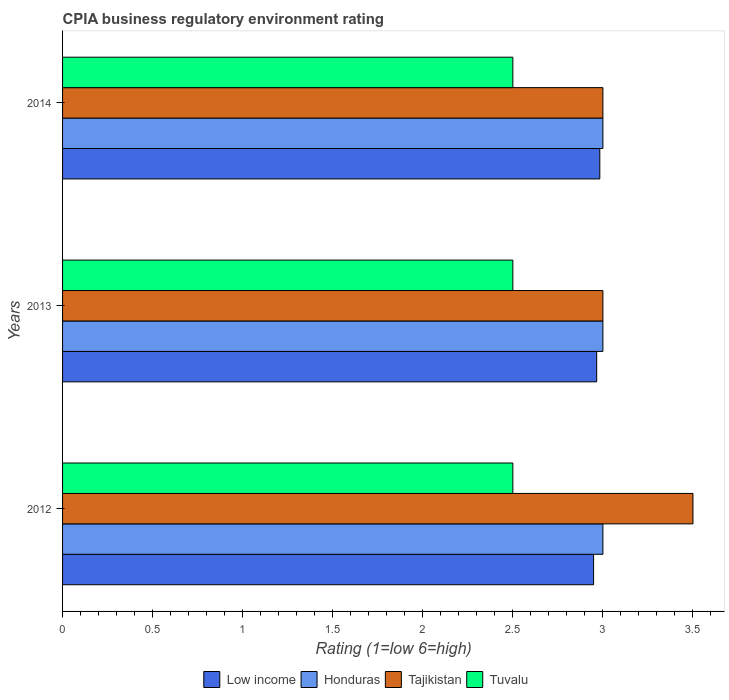How many different coloured bars are there?
Keep it short and to the point. 4. Are the number of bars per tick equal to the number of legend labels?
Make the answer very short. Yes. How many bars are there on the 2nd tick from the bottom?
Keep it short and to the point. 4. What is the CPIA rating in Honduras in 2014?
Give a very brief answer. 3. Across all years, what is the minimum CPIA rating in Low income?
Ensure brevity in your answer.  2.95. In which year was the CPIA rating in Low income minimum?
Keep it short and to the point. 2012. What is the total CPIA rating in Low income in the graph?
Offer a terse response. 8.9. What is the difference between the CPIA rating in Tajikistan in 2013 and that in 2014?
Offer a terse response. 0. What is the difference between the CPIA rating in Tuvalu in 2013 and the CPIA rating in Low income in 2012?
Provide a short and direct response. -0.45. What is the average CPIA rating in Tajikistan per year?
Your answer should be compact. 3.17. In the year 2012, what is the difference between the CPIA rating in Honduras and CPIA rating in Low income?
Give a very brief answer. 0.05. In how many years, is the CPIA rating in Honduras greater than 0.5 ?
Keep it short and to the point. 3. What is the ratio of the CPIA rating in Low income in 2012 to that in 2013?
Provide a short and direct response. 0.99. What is the difference between the highest and the second highest CPIA rating in Tuvalu?
Offer a terse response. 0. In how many years, is the CPIA rating in Honduras greater than the average CPIA rating in Honduras taken over all years?
Provide a succinct answer. 0. Is the sum of the CPIA rating in Honduras in 2012 and 2014 greater than the maximum CPIA rating in Tuvalu across all years?
Give a very brief answer. Yes. What does the 2nd bar from the top in 2013 represents?
Offer a terse response. Tajikistan. What does the 1st bar from the bottom in 2013 represents?
Provide a succinct answer. Low income. What is the difference between two consecutive major ticks on the X-axis?
Provide a short and direct response. 0.5. Does the graph contain any zero values?
Ensure brevity in your answer.  No. Does the graph contain grids?
Give a very brief answer. No. Where does the legend appear in the graph?
Provide a succinct answer. Bottom center. How many legend labels are there?
Your answer should be very brief. 4. What is the title of the graph?
Ensure brevity in your answer.  CPIA business regulatory environment rating. What is the label or title of the X-axis?
Offer a very short reply. Rating (1=low 6=high). What is the Rating (1=low 6=high) of Low income in 2012?
Offer a terse response. 2.95. What is the Rating (1=low 6=high) in Low income in 2013?
Your answer should be compact. 2.97. What is the Rating (1=low 6=high) of Honduras in 2013?
Your response must be concise. 3. What is the Rating (1=low 6=high) of Tuvalu in 2013?
Your response must be concise. 2.5. What is the Rating (1=low 6=high) in Low income in 2014?
Offer a terse response. 2.98. What is the Rating (1=low 6=high) of Honduras in 2014?
Your answer should be compact. 3. What is the Rating (1=low 6=high) in Tajikistan in 2014?
Offer a terse response. 3. Across all years, what is the maximum Rating (1=low 6=high) in Low income?
Your answer should be compact. 2.98. Across all years, what is the minimum Rating (1=low 6=high) in Low income?
Your response must be concise. 2.95. Across all years, what is the minimum Rating (1=low 6=high) in Tajikistan?
Give a very brief answer. 3. What is the total Rating (1=low 6=high) of Low income in the graph?
Your answer should be very brief. 8.9. What is the total Rating (1=low 6=high) in Honduras in the graph?
Provide a succinct answer. 9. What is the difference between the Rating (1=low 6=high) of Low income in 2012 and that in 2013?
Offer a terse response. -0.02. What is the difference between the Rating (1=low 6=high) of Tajikistan in 2012 and that in 2013?
Keep it short and to the point. 0.5. What is the difference between the Rating (1=low 6=high) of Low income in 2012 and that in 2014?
Your answer should be compact. -0.03. What is the difference between the Rating (1=low 6=high) of Tuvalu in 2012 and that in 2014?
Give a very brief answer. 0. What is the difference between the Rating (1=low 6=high) in Low income in 2013 and that in 2014?
Provide a short and direct response. -0.02. What is the difference between the Rating (1=low 6=high) of Low income in 2012 and the Rating (1=low 6=high) of Honduras in 2013?
Your response must be concise. -0.05. What is the difference between the Rating (1=low 6=high) of Low income in 2012 and the Rating (1=low 6=high) of Tajikistan in 2013?
Make the answer very short. -0.05. What is the difference between the Rating (1=low 6=high) in Low income in 2012 and the Rating (1=low 6=high) in Tuvalu in 2013?
Keep it short and to the point. 0.45. What is the difference between the Rating (1=low 6=high) of Honduras in 2012 and the Rating (1=low 6=high) of Tajikistan in 2013?
Keep it short and to the point. 0. What is the difference between the Rating (1=low 6=high) of Honduras in 2012 and the Rating (1=low 6=high) of Tuvalu in 2013?
Provide a short and direct response. 0.5. What is the difference between the Rating (1=low 6=high) in Tajikistan in 2012 and the Rating (1=low 6=high) in Tuvalu in 2013?
Make the answer very short. 1. What is the difference between the Rating (1=low 6=high) of Low income in 2012 and the Rating (1=low 6=high) of Honduras in 2014?
Keep it short and to the point. -0.05. What is the difference between the Rating (1=low 6=high) in Low income in 2012 and the Rating (1=low 6=high) in Tajikistan in 2014?
Your response must be concise. -0.05. What is the difference between the Rating (1=low 6=high) of Low income in 2012 and the Rating (1=low 6=high) of Tuvalu in 2014?
Offer a very short reply. 0.45. What is the difference between the Rating (1=low 6=high) of Tajikistan in 2012 and the Rating (1=low 6=high) of Tuvalu in 2014?
Your answer should be compact. 1. What is the difference between the Rating (1=low 6=high) of Low income in 2013 and the Rating (1=low 6=high) of Honduras in 2014?
Your answer should be compact. -0.03. What is the difference between the Rating (1=low 6=high) in Low income in 2013 and the Rating (1=low 6=high) in Tajikistan in 2014?
Make the answer very short. -0.03. What is the difference between the Rating (1=low 6=high) of Low income in 2013 and the Rating (1=low 6=high) of Tuvalu in 2014?
Provide a short and direct response. 0.47. What is the difference between the Rating (1=low 6=high) in Honduras in 2013 and the Rating (1=low 6=high) in Tajikistan in 2014?
Keep it short and to the point. 0. What is the difference between the Rating (1=low 6=high) of Honduras in 2013 and the Rating (1=low 6=high) of Tuvalu in 2014?
Keep it short and to the point. 0.5. What is the difference between the Rating (1=low 6=high) of Tajikistan in 2013 and the Rating (1=low 6=high) of Tuvalu in 2014?
Keep it short and to the point. 0.5. What is the average Rating (1=low 6=high) in Low income per year?
Your response must be concise. 2.97. What is the average Rating (1=low 6=high) in Honduras per year?
Offer a terse response. 3. What is the average Rating (1=low 6=high) of Tajikistan per year?
Provide a succinct answer. 3.17. In the year 2012, what is the difference between the Rating (1=low 6=high) of Low income and Rating (1=low 6=high) of Honduras?
Offer a terse response. -0.05. In the year 2012, what is the difference between the Rating (1=low 6=high) in Low income and Rating (1=low 6=high) in Tajikistan?
Provide a short and direct response. -0.55. In the year 2012, what is the difference between the Rating (1=low 6=high) of Low income and Rating (1=low 6=high) of Tuvalu?
Keep it short and to the point. 0.45. In the year 2012, what is the difference between the Rating (1=low 6=high) in Honduras and Rating (1=low 6=high) in Tajikistan?
Offer a terse response. -0.5. In the year 2012, what is the difference between the Rating (1=low 6=high) of Honduras and Rating (1=low 6=high) of Tuvalu?
Provide a short and direct response. 0.5. In the year 2013, what is the difference between the Rating (1=low 6=high) in Low income and Rating (1=low 6=high) in Honduras?
Keep it short and to the point. -0.03. In the year 2013, what is the difference between the Rating (1=low 6=high) of Low income and Rating (1=low 6=high) of Tajikistan?
Offer a terse response. -0.03. In the year 2013, what is the difference between the Rating (1=low 6=high) in Low income and Rating (1=low 6=high) in Tuvalu?
Your answer should be very brief. 0.47. In the year 2013, what is the difference between the Rating (1=low 6=high) in Tajikistan and Rating (1=low 6=high) in Tuvalu?
Ensure brevity in your answer.  0.5. In the year 2014, what is the difference between the Rating (1=low 6=high) of Low income and Rating (1=low 6=high) of Honduras?
Ensure brevity in your answer.  -0.02. In the year 2014, what is the difference between the Rating (1=low 6=high) of Low income and Rating (1=low 6=high) of Tajikistan?
Provide a short and direct response. -0.02. In the year 2014, what is the difference between the Rating (1=low 6=high) in Low income and Rating (1=low 6=high) in Tuvalu?
Make the answer very short. 0.48. In the year 2014, what is the difference between the Rating (1=low 6=high) in Tajikistan and Rating (1=low 6=high) in Tuvalu?
Your answer should be compact. 0.5. What is the ratio of the Rating (1=low 6=high) of Tuvalu in 2012 to that in 2013?
Your response must be concise. 1. What is the ratio of the Rating (1=low 6=high) in Low income in 2012 to that in 2014?
Offer a terse response. 0.99. What is the ratio of the Rating (1=low 6=high) in Tajikistan in 2012 to that in 2014?
Keep it short and to the point. 1.17. What is the ratio of the Rating (1=low 6=high) in Honduras in 2013 to that in 2014?
Your answer should be compact. 1. What is the ratio of the Rating (1=low 6=high) in Tajikistan in 2013 to that in 2014?
Keep it short and to the point. 1. What is the difference between the highest and the second highest Rating (1=low 6=high) in Low income?
Ensure brevity in your answer.  0.02. What is the difference between the highest and the second highest Rating (1=low 6=high) of Honduras?
Keep it short and to the point. 0. What is the difference between the highest and the second highest Rating (1=low 6=high) of Tajikistan?
Your response must be concise. 0.5. What is the difference between the highest and the second highest Rating (1=low 6=high) of Tuvalu?
Make the answer very short. 0. What is the difference between the highest and the lowest Rating (1=low 6=high) of Low income?
Offer a terse response. 0.03. What is the difference between the highest and the lowest Rating (1=low 6=high) in Honduras?
Your answer should be compact. 0. What is the difference between the highest and the lowest Rating (1=low 6=high) in Tajikistan?
Your answer should be very brief. 0.5. 